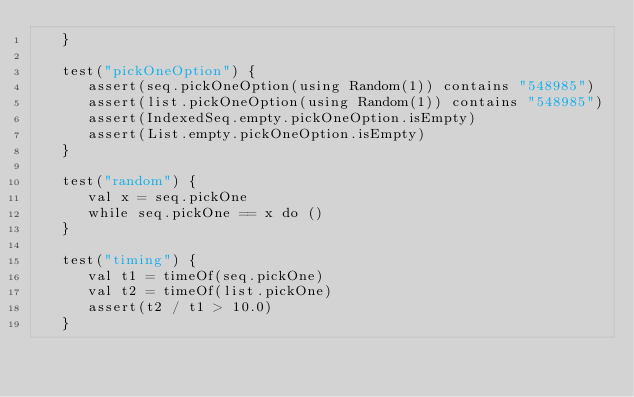Convert code to text. <code><loc_0><loc_0><loc_500><loc_500><_Scala_>   }

   test("pickOneOption") {
      assert(seq.pickOneOption(using Random(1)) contains "548985")
      assert(list.pickOneOption(using Random(1)) contains "548985")
      assert(IndexedSeq.empty.pickOneOption.isEmpty)
      assert(List.empty.pickOneOption.isEmpty)
   }

   test("random") {
      val x = seq.pickOne
      while seq.pickOne == x do ()
   }

   test("timing") {
      val t1 = timeOf(seq.pickOne)
      val t2 = timeOf(list.pickOne)
      assert(t2 / t1 > 10.0)
   }
</code> 